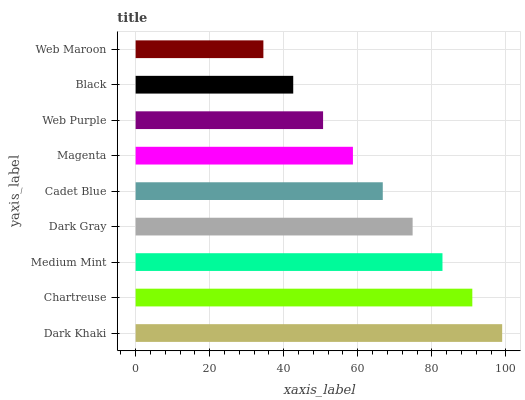Is Web Maroon the minimum?
Answer yes or no. Yes. Is Dark Khaki the maximum?
Answer yes or no. Yes. Is Chartreuse the minimum?
Answer yes or no. No. Is Chartreuse the maximum?
Answer yes or no. No. Is Dark Khaki greater than Chartreuse?
Answer yes or no. Yes. Is Chartreuse less than Dark Khaki?
Answer yes or no. Yes. Is Chartreuse greater than Dark Khaki?
Answer yes or no. No. Is Dark Khaki less than Chartreuse?
Answer yes or no. No. Is Cadet Blue the high median?
Answer yes or no. Yes. Is Cadet Blue the low median?
Answer yes or no. Yes. Is Medium Mint the high median?
Answer yes or no. No. Is Medium Mint the low median?
Answer yes or no. No. 